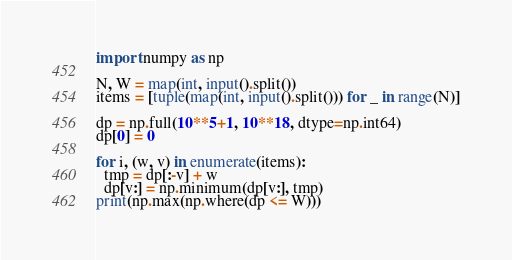Convert code to text. <code><loc_0><loc_0><loc_500><loc_500><_Python_>import numpy as np

N, W = map(int, input().split())
items = [tuple(map(int, input().split())) for _ in range(N)]

dp = np.full(10**5+1, 10**18, dtype=np.int64)
dp[0] = 0

for i, (w, v) in enumerate(items):
  tmp = dp[:-v] + w
  dp[v:] = np.minimum(dp[v:], tmp)
print(np.max(np.where(dp <= W)))</code> 